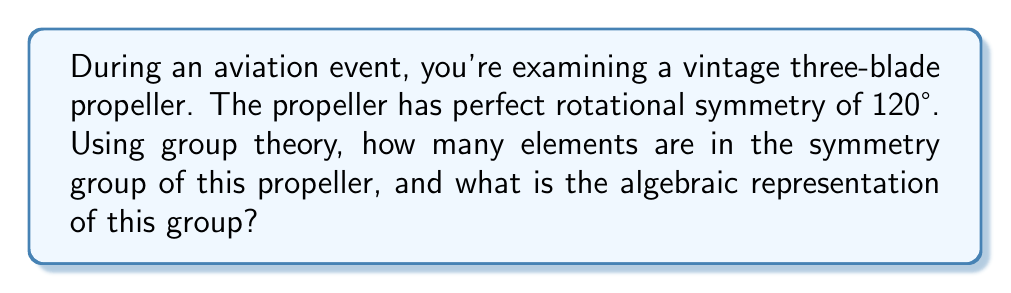Can you answer this question? Let's approach this step-by-step:

1) First, we need to identify the symmetries of the propeller:
   - It has rotational symmetry of 120° (or 2π/3 radians)
   - It also has rotational symmetry of 240° (or 4π/3 radians)
   - And of course, it has rotational symmetry of 360° (or 2π radians), which is equivalent to no rotation (identity)

2) These rotations form a cyclic group of order 3, which we can denote as $C_3$.

3) In addition to rotations, the propeller also has reflection symmetries:
   - It has 3 reflection lines, each passing through a blade and the center

4) The combination of these rotations and reflections forms the dihedral group $D_3$.

5) The order of a dihedral group $D_n$ is given by the formula: $|D_n| = 2n$

6) In this case, $n = 3$, so $|D_3| = 2(3) = 6$

7) Algebraically, $D_3$ can be represented as:
   $$D_3 = \{e, r, r^2, s, sr, sr^2\}$$
   where $e$ is the identity, $r$ is a rotation by 120°, and $s$ is a reflection.

8) This group is isomorphic to the symmetric group $S_3$, which permutes three objects.
Answer: 6 elements; $D_3 = \{e, r, r^2, s, sr, sr^2\}$ 